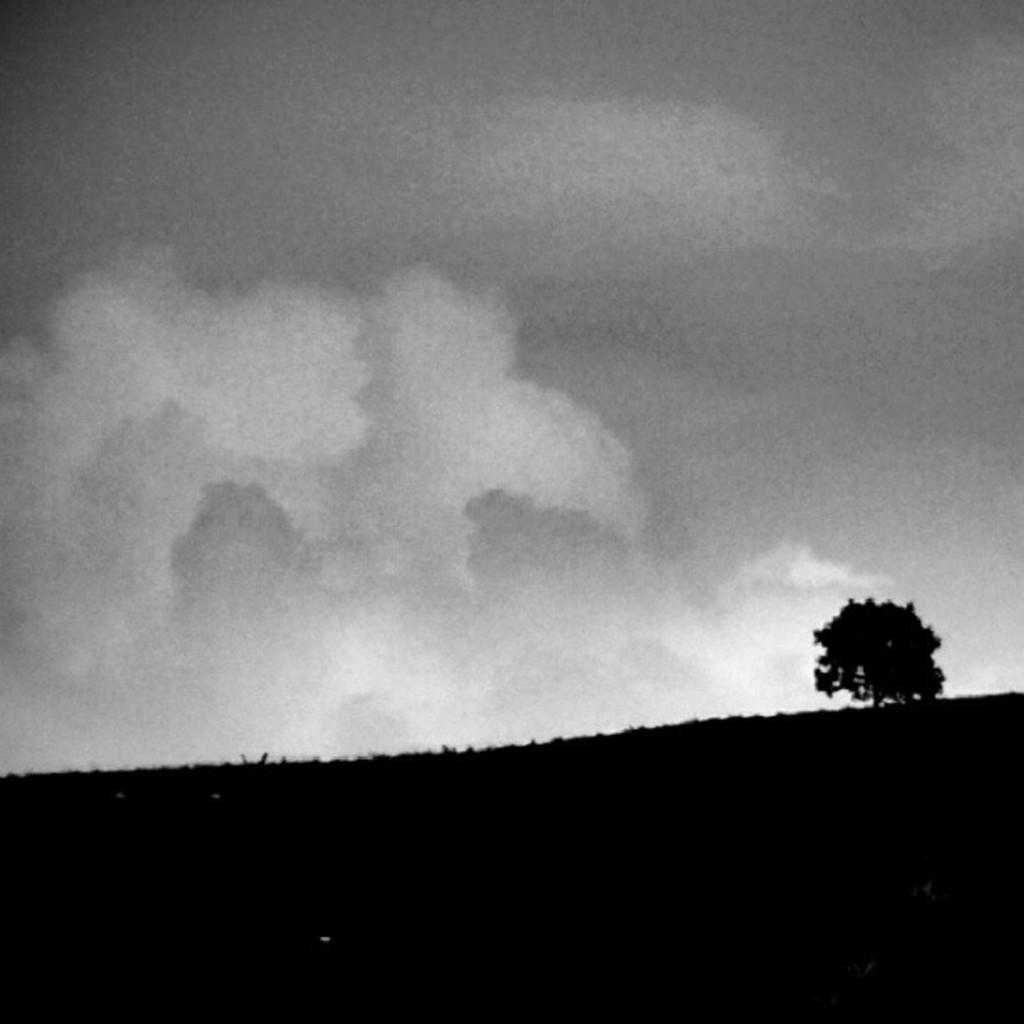What type of vegetation is at the bottom of the image? There are trees at the bottom of the image. What part of the natural environment is visible at the top of the image? The sky is visible at the top of the image. What type of paste is used to stick the trees together in the image? There is no paste used to stick the trees together in the image; they are naturally growing vegetation. What organization is responsible for maintaining the trees in the image? There is no organization mentioned or implied in the image; it simply depicts trees and the sky. 